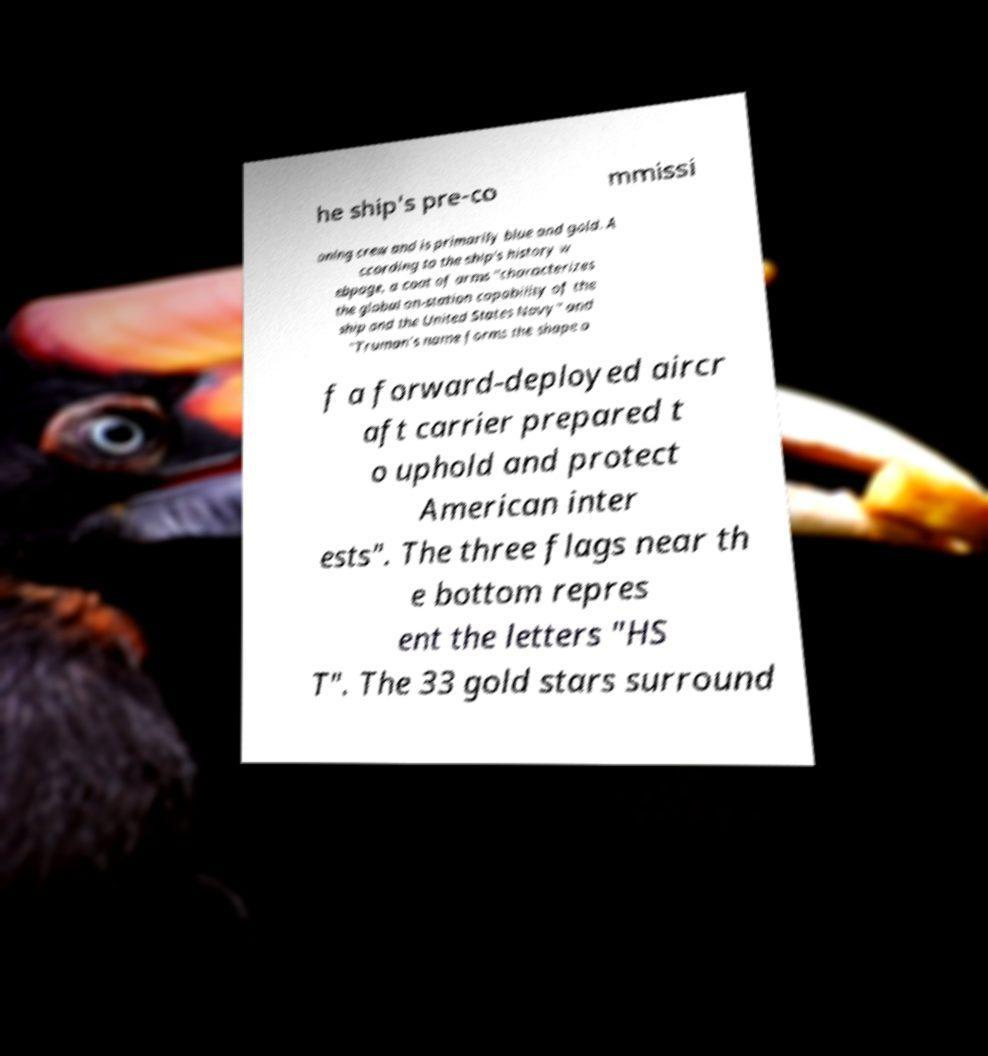There's text embedded in this image that I need extracted. Can you transcribe it verbatim? he ship's pre-co mmissi oning crew and is primarily blue and gold. A ccording to the ship's history w ebpage, a coat of arms "characterizes the global on-station capability of the ship and the United States Navy" and "Truman's name forms the shape o f a forward-deployed aircr aft carrier prepared t o uphold and protect American inter ests". The three flags near th e bottom repres ent the letters "HS T". The 33 gold stars surround 